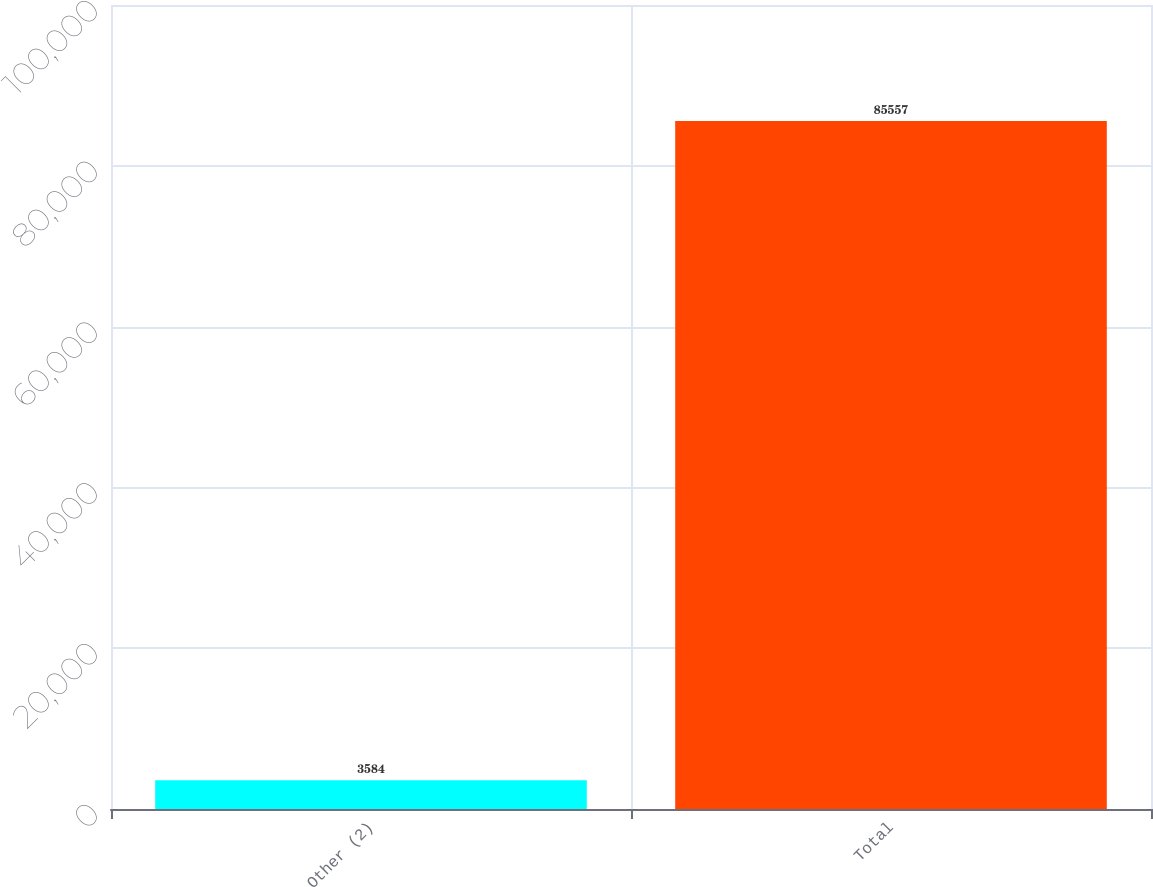Convert chart. <chart><loc_0><loc_0><loc_500><loc_500><bar_chart><fcel>Other (2)<fcel>Total<nl><fcel>3584<fcel>85557<nl></chart> 